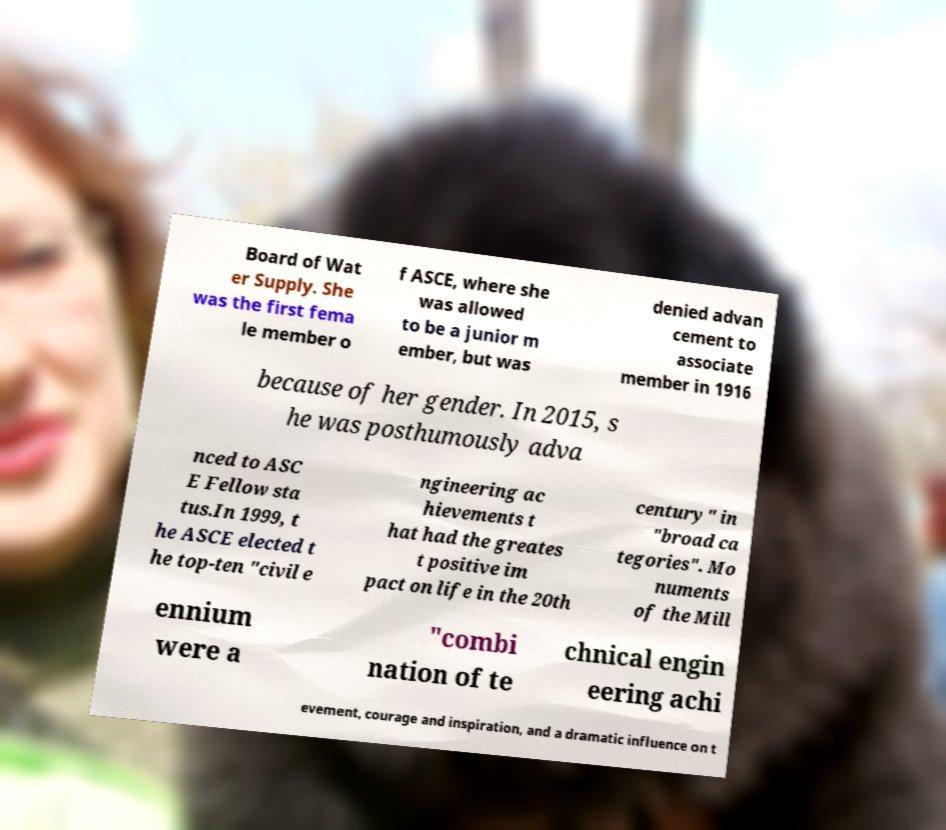Please read and relay the text visible in this image. What does it say? Board of Wat er Supply. She was the first fema le member o f ASCE, where she was allowed to be a junior m ember, but was denied advan cement to associate member in 1916 because of her gender. In 2015, s he was posthumously adva nced to ASC E Fellow sta tus.In 1999, t he ASCE elected t he top-ten "civil e ngineering ac hievements t hat had the greates t positive im pact on life in the 20th century" in "broad ca tegories". Mo numents of the Mill ennium were a "combi nation of te chnical engin eering achi evement, courage and inspiration, and a dramatic influence on t 